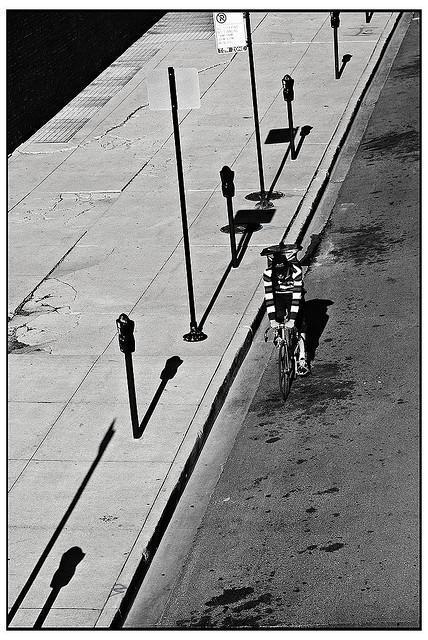What kind of vehicle is the person driving up next to the street?
Choose the right answer from the provided options to respond to the question.
Options: Bike, pickup, streetsweeper, van. Bike. 